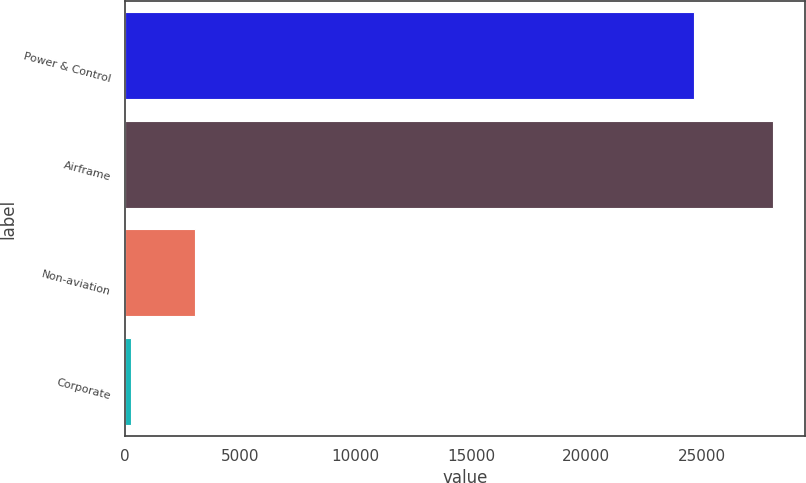Convert chart to OTSL. <chart><loc_0><loc_0><loc_500><loc_500><bar_chart><fcel>Power & Control<fcel>Airframe<fcel>Non-aviation<fcel>Corporate<nl><fcel>24664<fcel>28086<fcel>3017.4<fcel>232<nl></chart> 